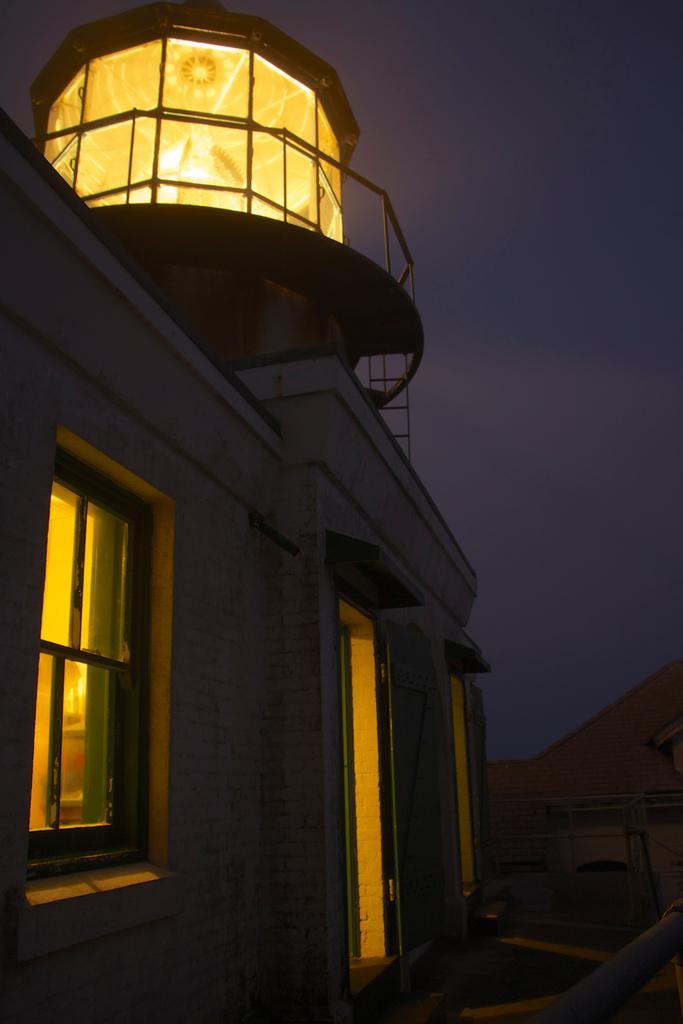Could you give a brief overview of what you see in this image? On the left side of the picture there is a building, to the building there are window, door and railing. On the right there is railing. The picture is taken at night time. 